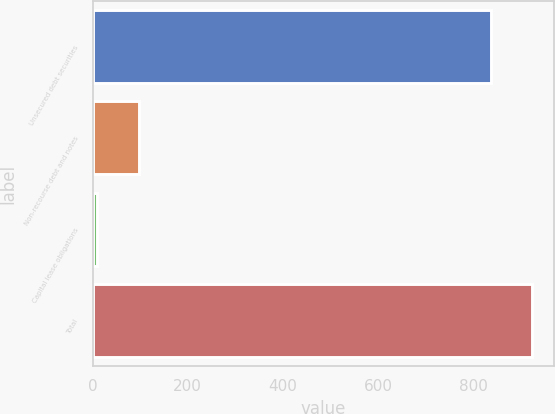Convert chart to OTSL. <chart><loc_0><loc_0><loc_500><loc_500><bar_chart><fcel>Unsecured debt securities<fcel>Non-recourse debt and notes<fcel>Capital lease obligations<fcel>Total<nl><fcel>837<fcel>96.9<fcel>10<fcel>923.9<nl></chart> 